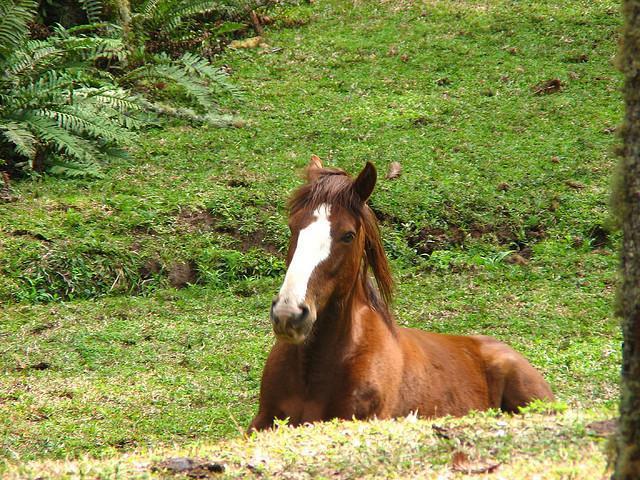How many horses are there?
Give a very brief answer. 1. How many people are on the bench?
Give a very brief answer. 0. 